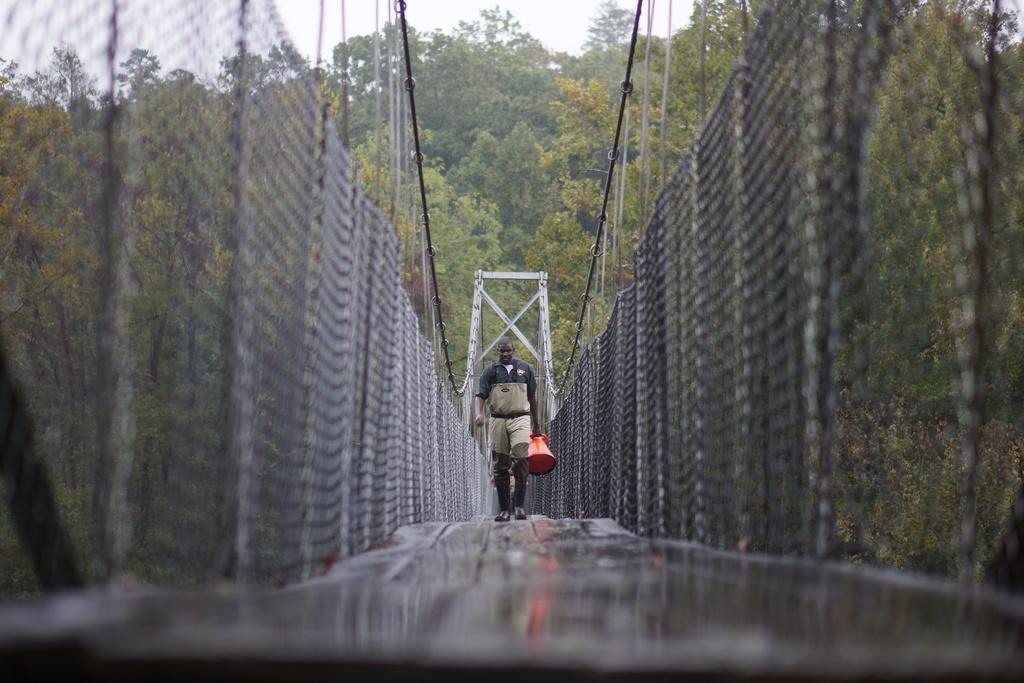Please provide a concise description of this image. In this image we can see a person walking on a bridge and the person is carrying an object. Beside the person we can see fencing. Behind the person there are group of trees. At the top we can see the sky. 